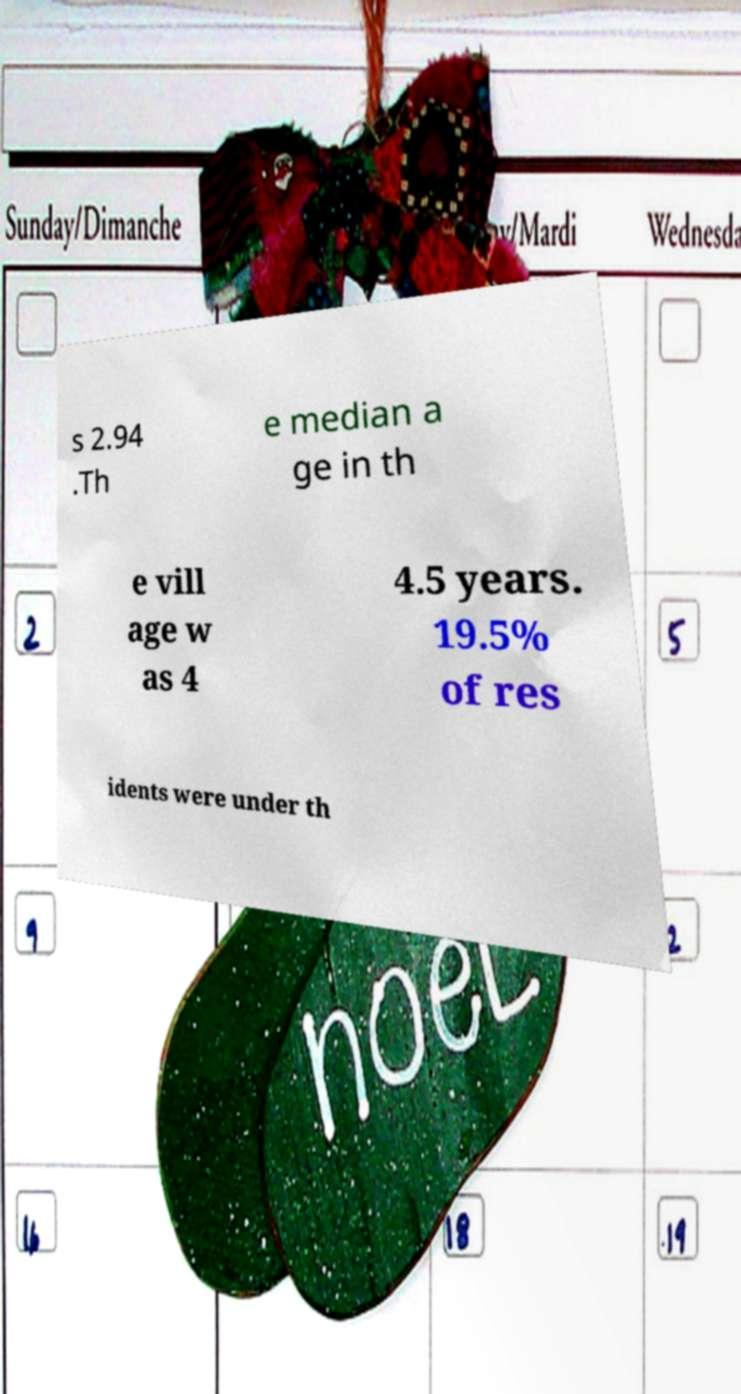What messages or text are displayed in this image? I need them in a readable, typed format. s 2.94 .Th e median a ge in th e vill age w as 4 4.5 years. 19.5% of res idents were under th 